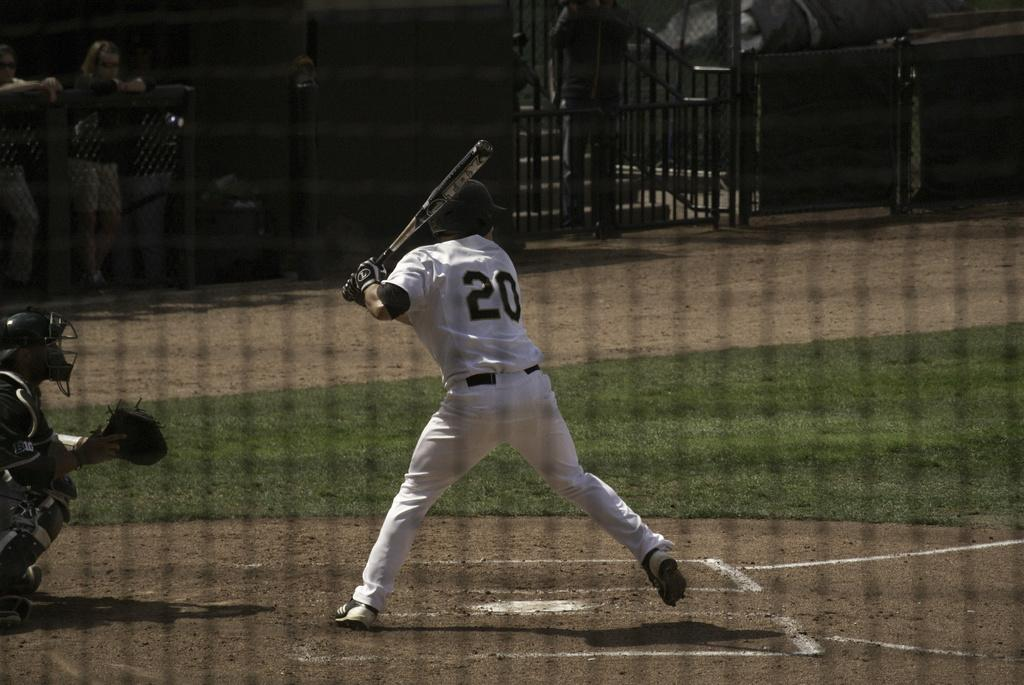Provide a one-sentence caption for the provided image. The TPX baseball bat is gripped by the player. 